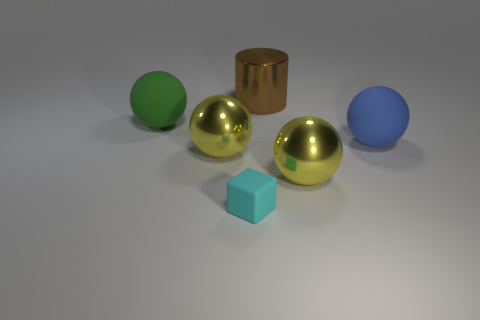How many objects are either big blue metal balls or balls in front of the big green rubber thing?
Offer a terse response. 3. There is a metallic object in front of the large shiny ball that is left of the matte cube; how many yellow metal objects are right of it?
Your response must be concise. 0. How many brown rubber spheres are there?
Provide a succinct answer. 0. There is a rubber sphere on the left side of the blue rubber sphere; does it have the same size as the big cylinder?
Offer a very short reply. Yes. What number of metallic objects are either big green things or cyan cubes?
Your answer should be compact. 0. There is a big yellow ball that is left of the tiny thing; how many blue matte balls are behind it?
Your answer should be compact. 1. There is a big metallic object that is both in front of the large brown metallic object and on the right side of the cyan block; what is its shape?
Give a very brief answer. Sphere. The yellow sphere that is to the right of the matte object in front of the metallic ball on the right side of the cyan block is made of what material?
Keep it short and to the point. Metal. What material is the big green thing?
Keep it short and to the point. Rubber. Is the material of the big green ball the same as the large yellow ball on the right side of the big cylinder?
Your answer should be very brief. No. 